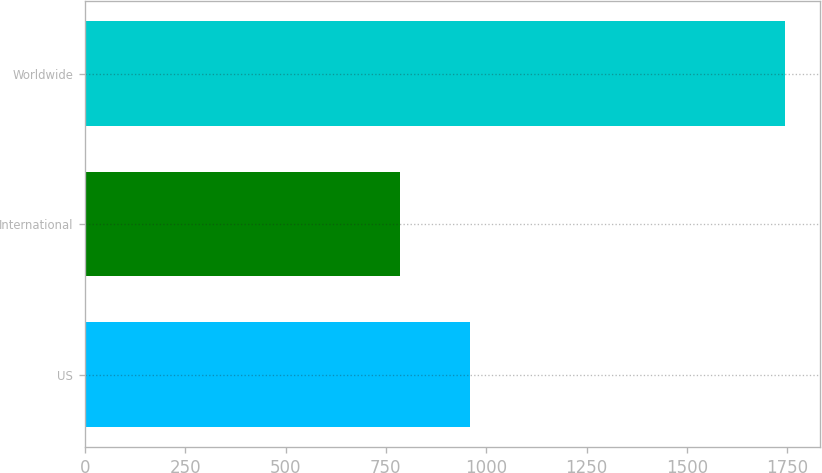<chart> <loc_0><loc_0><loc_500><loc_500><bar_chart><fcel>US<fcel>International<fcel>Worldwide<nl><fcel>959<fcel>786<fcel>1745<nl></chart> 